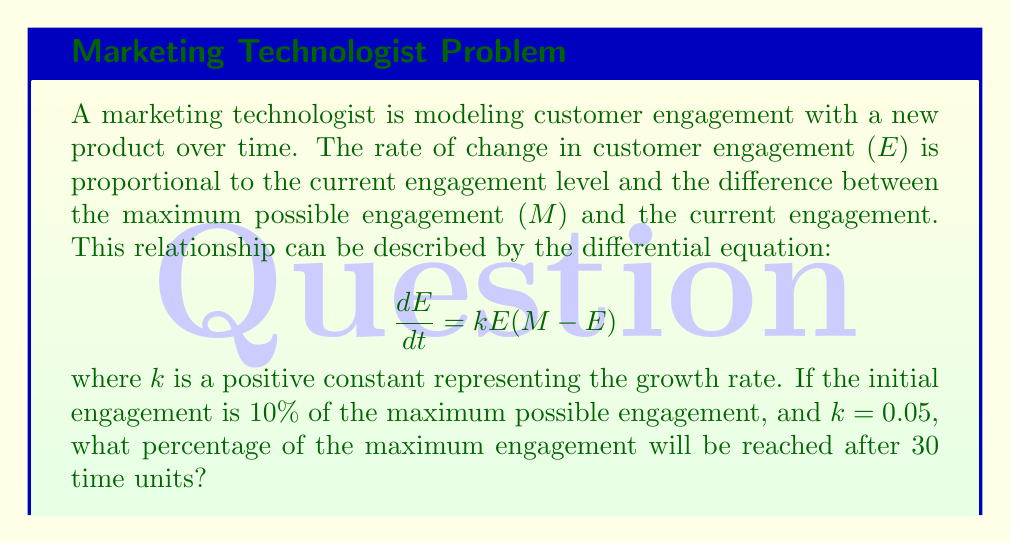Can you answer this question? To solve this problem, we'll follow these steps:

1) First, we recognize this as a logistic growth equation. The solution to this equation is:

   $$E(t) = \frac{M}{1 + (\frac{M}{E_0} - 1)e^{-kMt}}$$

   where $E_0$ is the initial engagement level.

2) We're given that $E_0 = 0.1M$ (10% of maximum), $k = 0.05$, and we need to find $E(30)$.

3) Substituting these values into our solution:

   $$E(30) = \frac{M}{1 + (\frac{M}{0.1M} - 1)e^{-0.05M(30)}}$$

4) Simplify:

   $$E(30) = \frac{M}{1 + (10 - 1)e^{-1.5M}}$$
   
   $$E(30) = \frac{M}{1 + 9e^{-1.5M}}$$

5) To express this as a percentage of $M$, we divide by $M$:

   $$\frac{E(30)}{M} = \frac{1}{1 + 9e^{-1.5M}}$$

6) The $M$ in the exponent cancels out because it's multiplied by both $k$ and $t$, so we can treat it as a constant. This gives us:

   $$\frac{E(30)}{M} = \frac{1}{1 + 9e^{-1.5}} \approx 0.8175$$

7) Convert to a percentage:

   $0.8175 * 100\% = 81.75\%$
Answer: 81.75% 